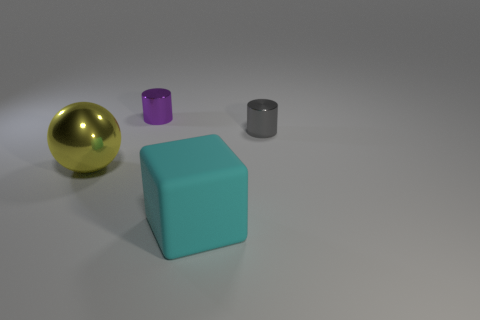Add 2 small gray metallic cubes. How many objects exist? 6 Subtract all large shiny things. Subtract all matte things. How many objects are left? 2 Add 2 tiny cylinders. How many tiny cylinders are left? 4 Add 4 yellow things. How many yellow things exist? 5 Subtract 0 gray balls. How many objects are left? 4 